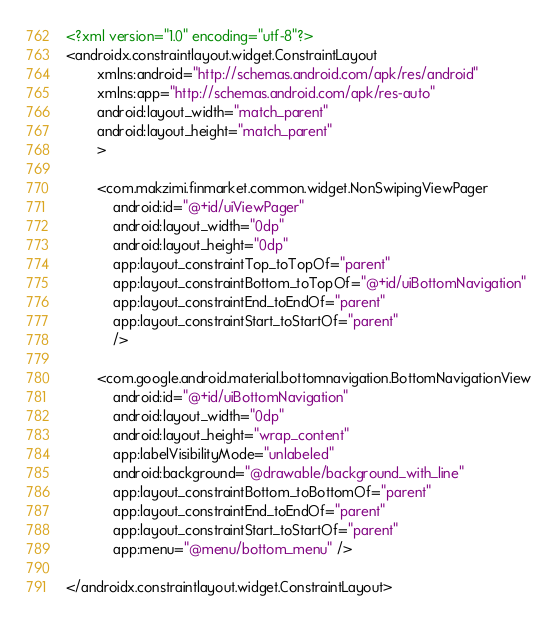Convert code to text. <code><loc_0><loc_0><loc_500><loc_500><_XML_><?xml version="1.0" encoding="utf-8"?>
<androidx.constraintlayout.widget.ConstraintLayout
        xmlns:android="http://schemas.android.com/apk/res/android"
        xmlns:app="http://schemas.android.com/apk/res-auto"
        android:layout_width="match_parent"
        android:layout_height="match_parent"
        >

        <com.makzimi.finmarket.common.widget.NonSwipingViewPager
            android:id="@+id/uiViewPager"
            android:layout_width="0dp"
            android:layout_height="0dp"
            app:layout_constraintTop_toTopOf="parent"
            app:layout_constraintBottom_toTopOf="@+id/uiBottomNavigation"
            app:layout_constraintEnd_toEndOf="parent"
            app:layout_constraintStart_toStartOf="parent"
            />

        <com.google.android.material.bottomnavigation.BottomNavigationView
            android:id="@+id/uiBottomNavigation"
            android:layout_width="0dp"
            android:layout_height="wrap_content"
            app:labelVisibilityMode="unlabeled"
            android:background="@drawable/background_with_line"
            app:layout_constraintBottom_toBottomOf="parent"
            app:layout_constraintEnd_toEndOf="parent"
            app:layout_constraintStart_toStartOf="parent"
            app:menu="@menu/bottom_menu" />

</androidx.constraintlayout.widget.ConstraintLayout></code> 